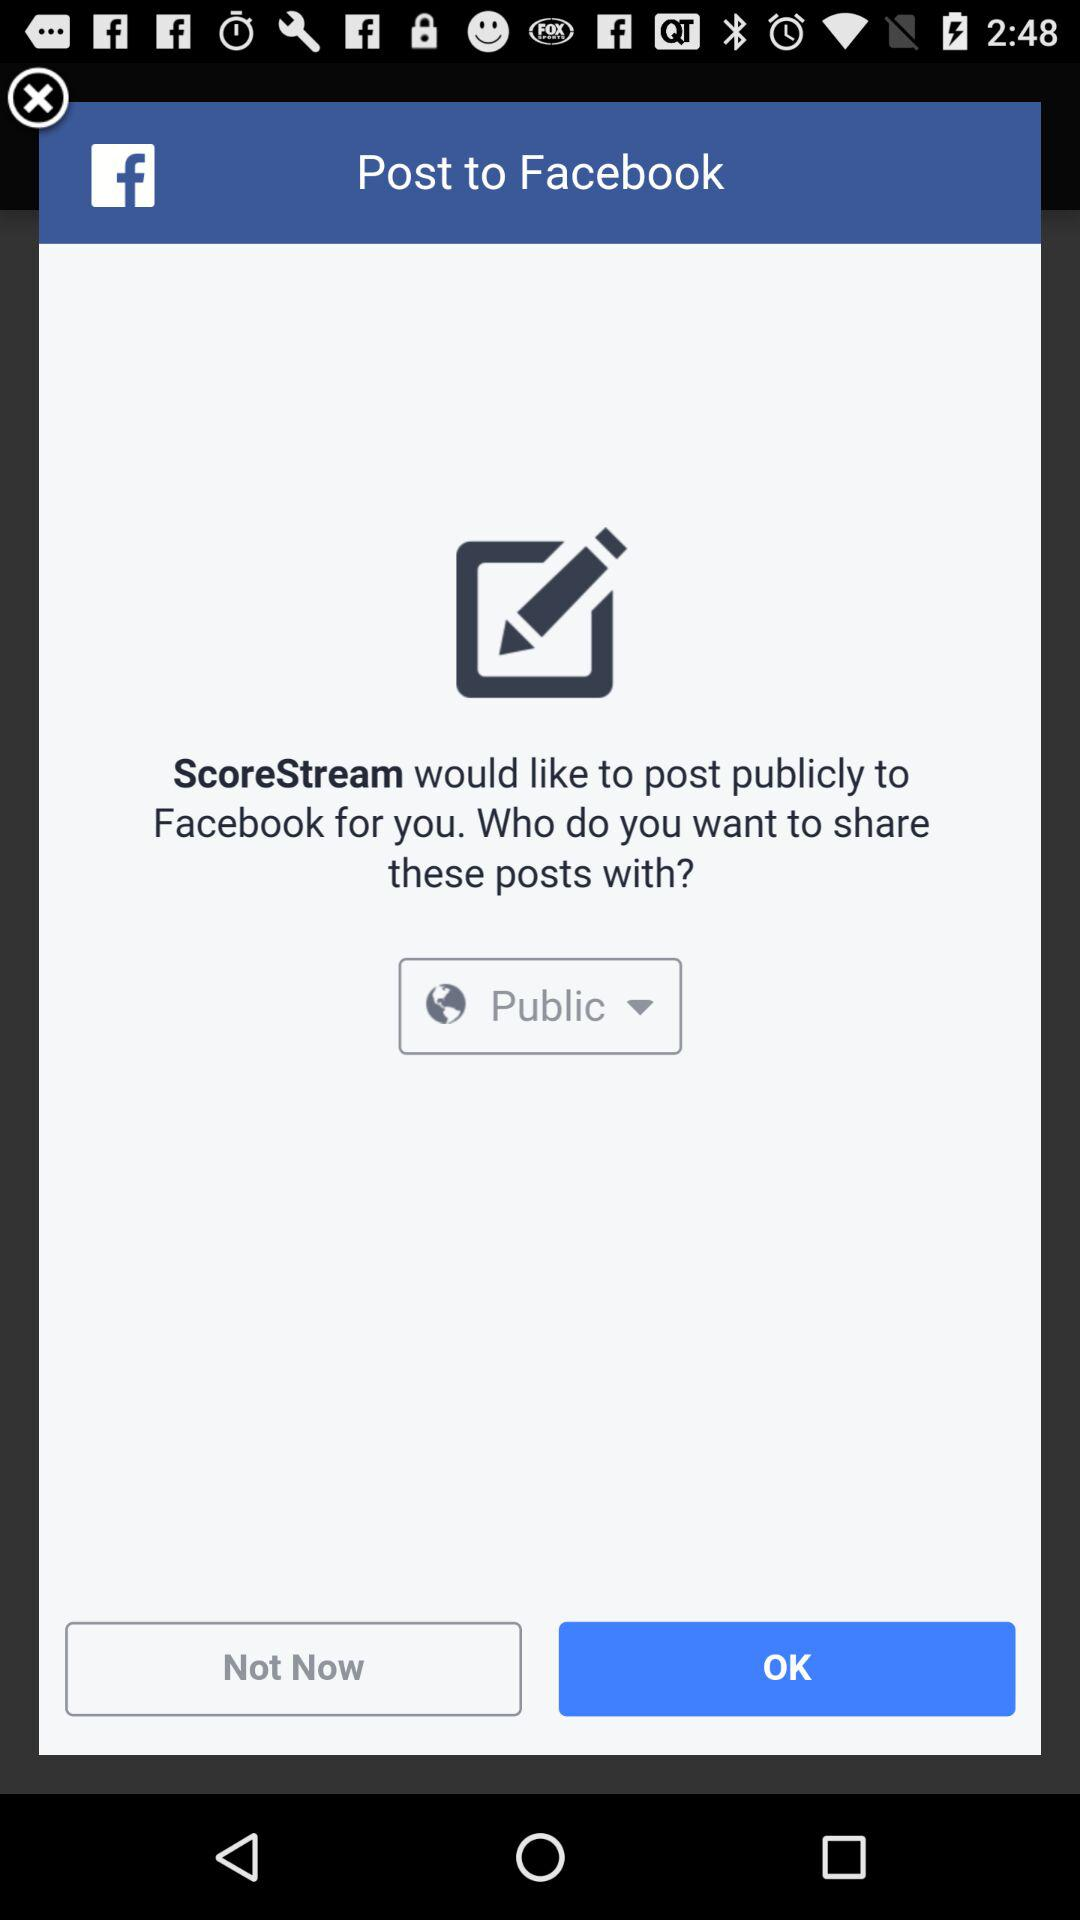What is the selected privacy? The selected privacy is "Public". 